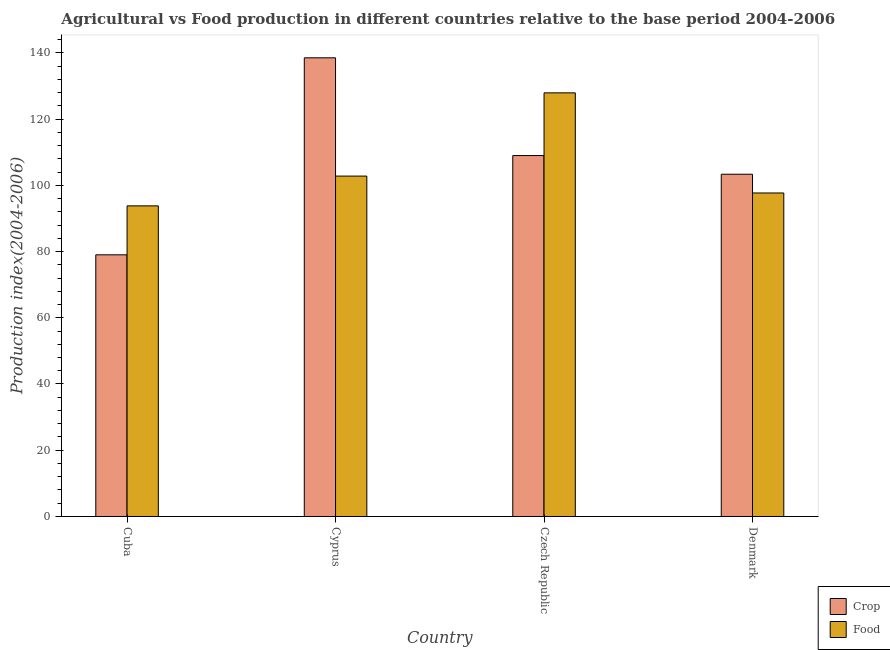How many groups of bars are there?
Your answer should be very brief. 4. Are the number of bars on each tick of the X-axis equal?
Give a very brief answer. Yes. What is the label of the 2nd group of bars from the left?
Offer a terse response. Cyprus. In how many cases, is the number of bars for a given country not equal to the number of legend labels?
Offer a terse response. 0. What is the food production index in Czech Republic?
Your answer should be very brief. 127.9. Across all countries, what is the maximum food production index?
Your answer should be very brief. 127.9. Across all countries, what is the minimum crop production index?
Give a very brief answer. 79. In which country was the food production index maximum?
Keep it short and to the point. Czech Republic. In which country was the food production index minimum?
Offer a very short reply. Cuba. What is the total food production index in the graph?
Ensure brevity in your answer.  422.12. What is the difference between the crop production index in Cuba and that in Denmark?
Your answer should be compact. -24.33. What is the difference between the crop production index in Denmark and the food production index in Cyprus?
Ensure brevity in your answer.  0.56. What is the average crop production index per country?
Your answer should be compact. 107.44. What is the difference between the crop production index and food production index in Cyprus?
Your response must be concise. 35.71. In how many countries, is the crop production index greater than 48 ?
Make the answer very short. 4. What is the ratio of the crop production index in Cuba to that in Czech Republic?
Your answer should be very brief. 0.72. Is the difference between the crop production index in Cyprus and Czech Republic greater than the difference between the food production index in Cyprus and Czech Republic?
Provide a succinct answer. Yes. What is the difference between the highest and the second highest food production index?
Your answer should be very brief. 25.13. What is the difference between the highest and the lowest food production index?
Your answer should be compact. 34.12. In how many countries, is the crop production index greater than the average crop production index taken over all countries?
Your answer should be compact. 2. Is the sum of the food production index in Cuba and Czech Republic greater than the maximum crop production index across all countries?
Offer a terse response. Yes. What does the 1st bar from the left in Denmark represents?
Provide a succinct answer. Crop. What does the 2nd bar from the right in Denmark represents?
Give a very brief answer. Crop. Are all the bars in the graph horizontal?
Make the answer very short. No. What is the difference between two consecutive major ticks on the Y-axis?
Offer a very short reply. 20. Are the values on the major ticks of Y-axis written in scientific E-notation?
Provide a short and direct response. No. Does the graph contain any zero values?
Provide a short and direct response. No. Does the graph contain grids?
Keep it short and to the point. No. What is the title of the graph?
Provide a succinct answer. Agricultural vs Food production in different countries relative to the base period 2004-2006. What is the label or title of the X-axis?
Provide a succinct answer. Country. What is the label or title of the Y-axis?
Provide a succinct answer. Production index(2004-2006). What is the Production index(2004-2006) in Crop in Cuba?
Make the answer very short. 79. What is the Production index(2004-2006) in Food in Cuba?
Provide a short and direct response. 93.78. What is the Production index(2004-2006) of Crop in Cyprus?
Your response must be concise. 138.48. What is the Production index(2004-2006) of Food in Cyprus?
Provide a short and direct response. 102.77. What is the Production index(2004-2006) of Crop in Czech Republic?
Offer a terse response. 108.97. What is the Production index(2004-2006) of Food in Czech Republic?
Your answer should be compact. 127.9. What is the Production index(2004-2006) of Crop in Denmark?
Ensure brevity in your answer.  103.33. What is the Production index(2004-2006) in Food in Denmark?
Your response must be concise. 97.67. Across all countries, what is the maximum Production index(2004-2006) of Crop?
Provide a succinct answer. 138.48. Across all countries, what is the maximum Production index(2004-2006) in Food?
Make the answer very short. 127.9. Across all countries, what is the minimum Production index(2004-2006) of Crop?
Make the answer very short. 79. Across all countries, what is the minimum Production index(2004-2006) in Food?
Offer a terse response. 93.78. What is the total Production index(2004-2006) of Crop in the graph?
Your answer should be very brief. 429.78. What is the total Production index(2004-2006) of Food in the graph?
Provide a succinct answer. 422.12. What is the difference between the Production index(2004-2006) in Crop in Cuba and that in Cyprus?
Your response must be concise. -59.48. What is the difference between the Production index(2004-2006) in Food in Cuba and that in Cyprus?
Your answer should be very brief. -8.99. What is the difference between the Production index(2004-2006) of Crop in Cuba and that in Czech Republic?
Provide a succinct answer. -29.97. What is the difference between the Production index(2004-2006) of Food in Cuba and that in Czech Republic?
Your answer should be very brief. -34.12. What is the difference between the Production index(2004-2006) of Crop in Cuba and that in Denmark?
Keep it short and to the point. -24.33. What is the difference between the Production index(2004-2006) of Food in Cuba and that in Denmark?
Your response must be concise. -3.89. What is the difference between the Production index(2004-2006) of Crop in Cyprus and that in Czech Republic?
Give a very brief answer. 29.51. What is the difference between the Production index(2004-2006) in Food in Cyprus and that in Czech Republic?
Your response must be concise. -25.13. What is the difference between the Production index(2004-2006) in Crop in Cyprus and that in Denmark?
Ensure brevity in your answer.  35.15. What is the difference between the Production index(2004-2006) of Food in Cyprus and that in Denmark?
Keep it short and to the point. 5.1. What is the difference between the Production index(2004-2006) in Crop in Czech Republic and that in Denmark?
Your answer should be very brief. 5.64. What is the difference between the Production index(2004-2006) of Food in Czech Republic and that in Denmark?
Your response must be concise. 30.23. What is the difference between the Production index(2004-2006) of Crop in Cuba and the Production index(2004-2006) of Food in Cyprus?
Provide a succinct answer. -23.77. What is the difference between the Production index(2004-2006) in Crop in Cuba and the Production index(2004-2006) in Food in Czech Republic?
Make the answer very short. -48.9. What is the difference between the Production index(2004-2006) in Crop in Cuba and the Production index(2004-2006) in Food in Denmark?
Ensure brevity in your answer.  -18.67. What is the difference between the Production index(2004-2006) of Crop in Cyprus and the Production index(2004-2006) of Food in Czech Republic?
Keep it short and to the point. 10.58. What is the difference between the Production index(2004-2006) in Crop in Cyprus and the Production index(2004-2006) in Food in Denmark?
Provide a succinct answer. 40.81. What is the difference between the Production index(2004-2006) in Crop in Czech Republic and the Production index(2004-2006) in Food in Denmark?
Provide a succinct answer. 11.3. What is the average Production index(2004-2006) in Crop per country?
Give a very brief answer. 107.44. What is the average Production index(2004-2006) of Food per country?
Offer a terse response. 105.53. What is the difference between the Production index(2004-2006) of Crop and Production index(2004-2006) of Food in Cuba?
Your response must be concise. -14.78. What is the difference between the Production index(2004-2006) of Crop and Production index(2004-2006) of Food in Cyprus?
Keep it short and to the point. 35.71. What is the difference between the Production index(2004-2006) of Crop and Production index(2004-2006) of Food in Czech Republic?
Your response must be concise. -18.93. What is the difference between the Production index(2004-2006) in Crop and Production index(2004-2006) in Food in Denmark?
Your response must be concise. 5.66. What is the ratio of the Production index(2004-2006) in Crop in Cuba to that in Cyprus?
Your answer should be compact. 0.57. What is the ratio of the Production index(2004-2006) in Food in Cuba to that in Cyprus?
Give a very brief answer. 0.91. What is the ratio of the Production index(2004-2006) in Crop in Cuba to that in Czech Republic?
Keep it short and to the point. 0.72. What is the ratio of the Production index(2004-2006) of Food in Cuba to that in Czech Republic?
Offer a very short reply. 0.73. What is the ratio of the Production index(2004-2006) of Crop in Cuba to that in Denmark?
Make the answer very short. 0.76. What is the ratio of the Production index(2004-2006) of Food in Cuba to that in Denmark?
Keep it short and to the point. 0.96. What is the ratio of the Production index(2004-2006) in Crop in Cyprus to that in Czech Republic?
Ensure brevity in your answer.  1.27. What is the ratio of the Production index(2004-2006) in Food in Cyprus to that in Czech Republic?
Your response must be concise. 0.8. What is the ratio of the Production index(2004-2006) in Crop in Cyprus to that in Denmark?
Keep it short and to the point. 1.34. What is the ratio of the Production index(2004-2006) in Food in Cyprus to that in Denmark?
Offer a very short reply. 1.05. What is the ratio of the Production index(2004-2006) of Crop in Czech Republic to that in Denmark?
Provide a succinct answer. 1.05. What is the ratio of the Production index(2004-2006) in Food in Czech Republic to that in Denmark?
Provide a short and direct response. 1.31. What is the difference between the highest and the second highest Production index(2004-2006) of Crop?
Provide a short and direct response. 29.51. What is the difference between the highest and the second highest Production index(2004-2006) of Food?
Offer a terse response. 25.13. What is the difference between the highest and the lowest Production index(2004-2006) in Crop?
Your response must be concise. 59.48. What is the difference between the highest and the lowest Production index(2004-2006) in Food?
Provide a short and direct response. 34.12. 